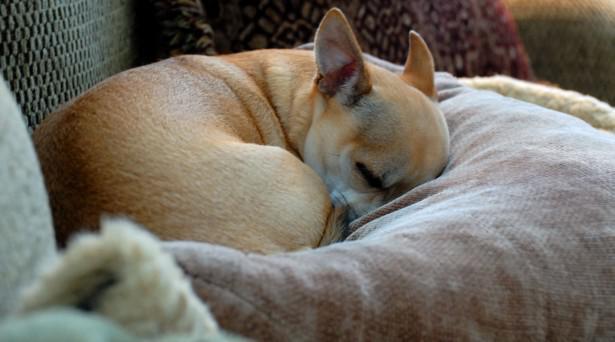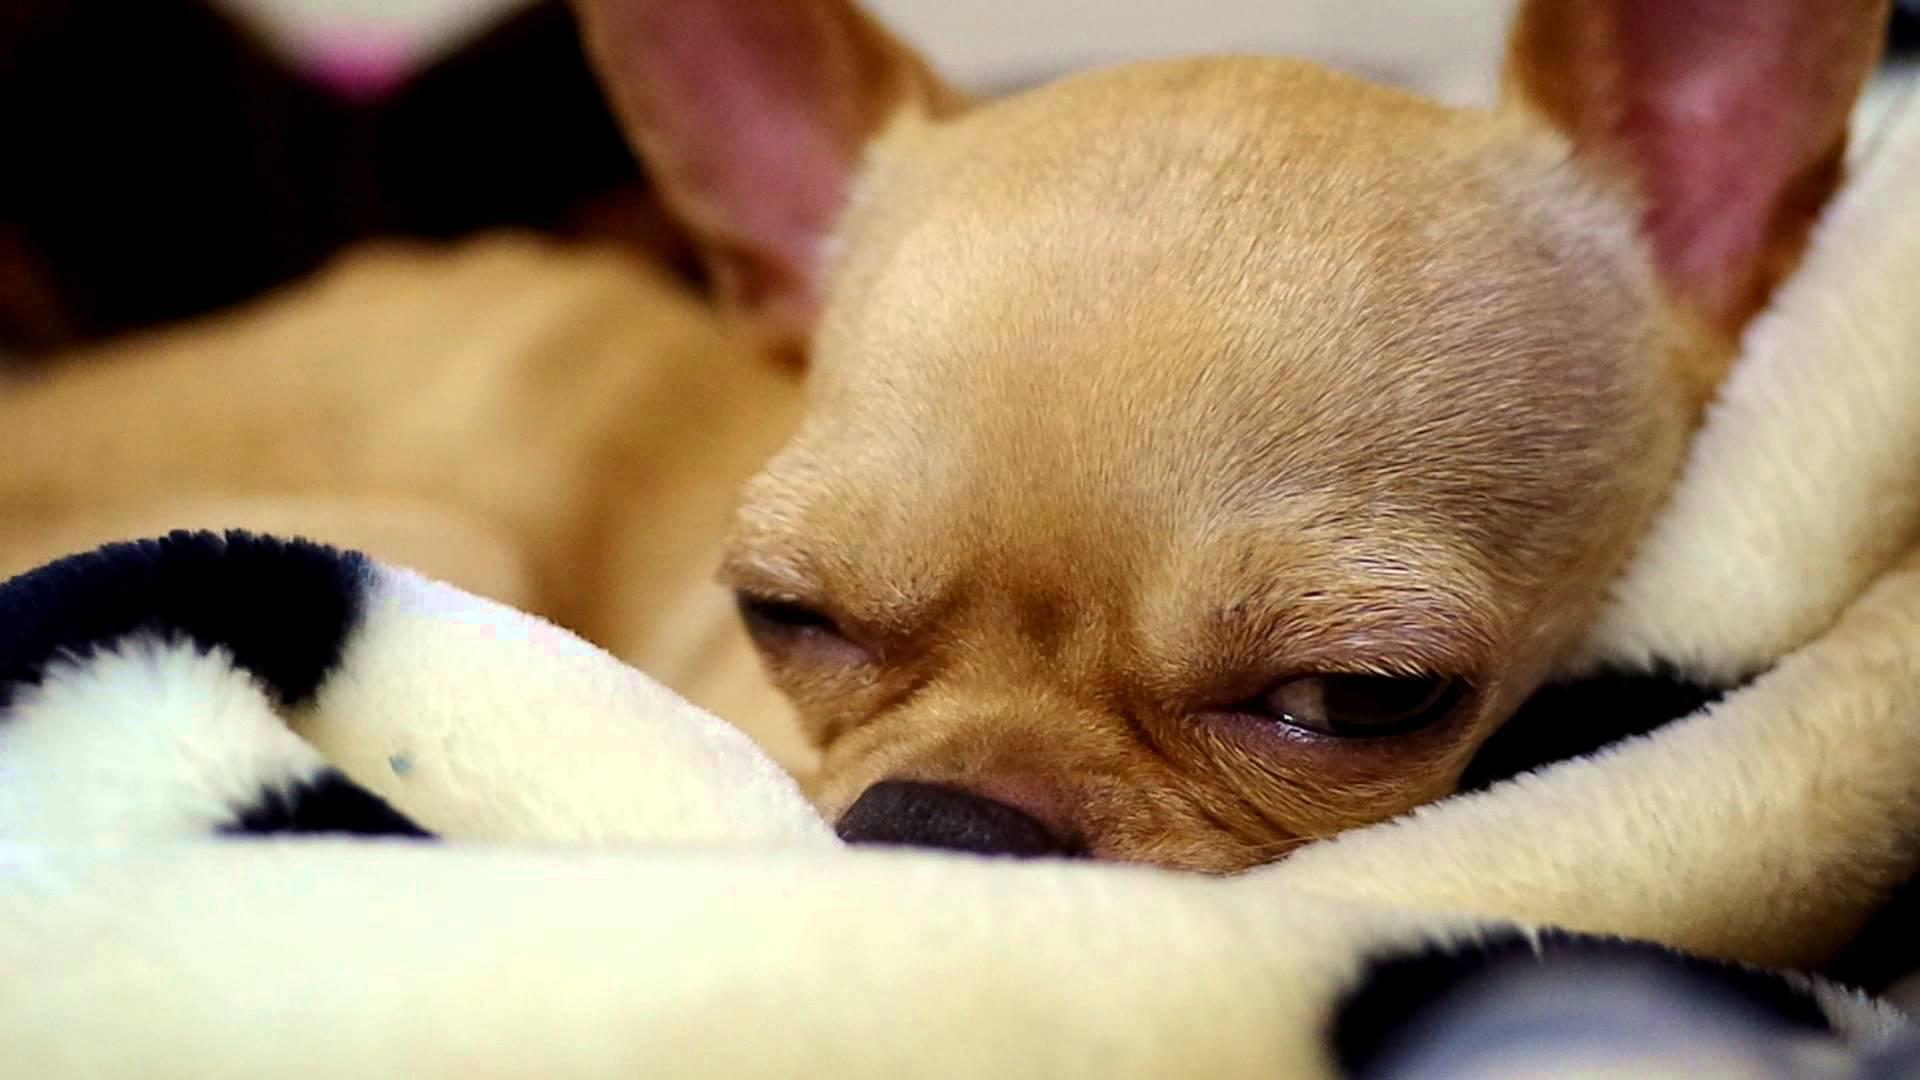The first image is the image on the left, the second image is the image on the right. Analyze the images presented: Is the assertion "A puppy with dark and light fur is sleeping with a dimensional object between its paws." valid? Answer yes or no. No. The first image is the image on the left, the second image is the image on the right. For the images displayed, is the sentence "In the left image, a dog is cuddling another object." factually correct? Answer yes or no. No. 